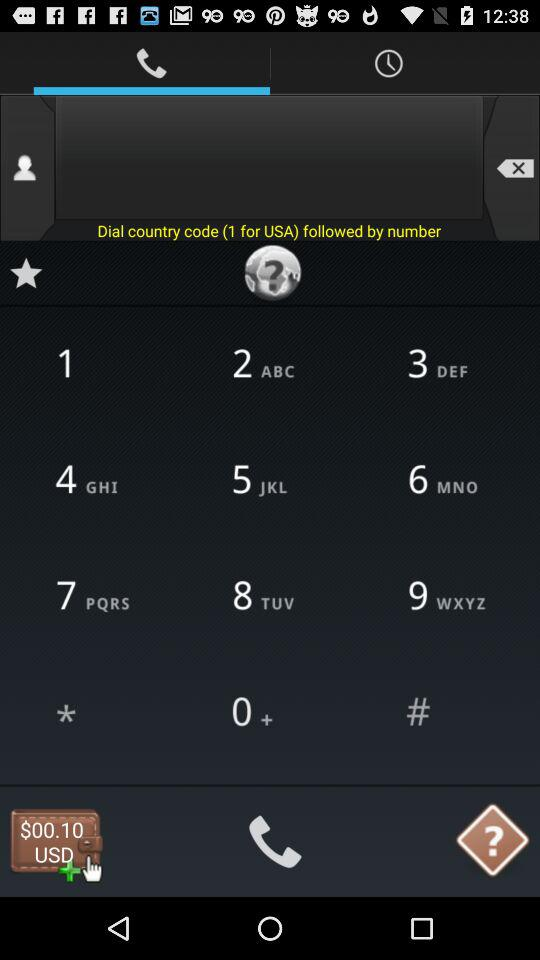Which tab is selected? The selected tab is "Calls". 